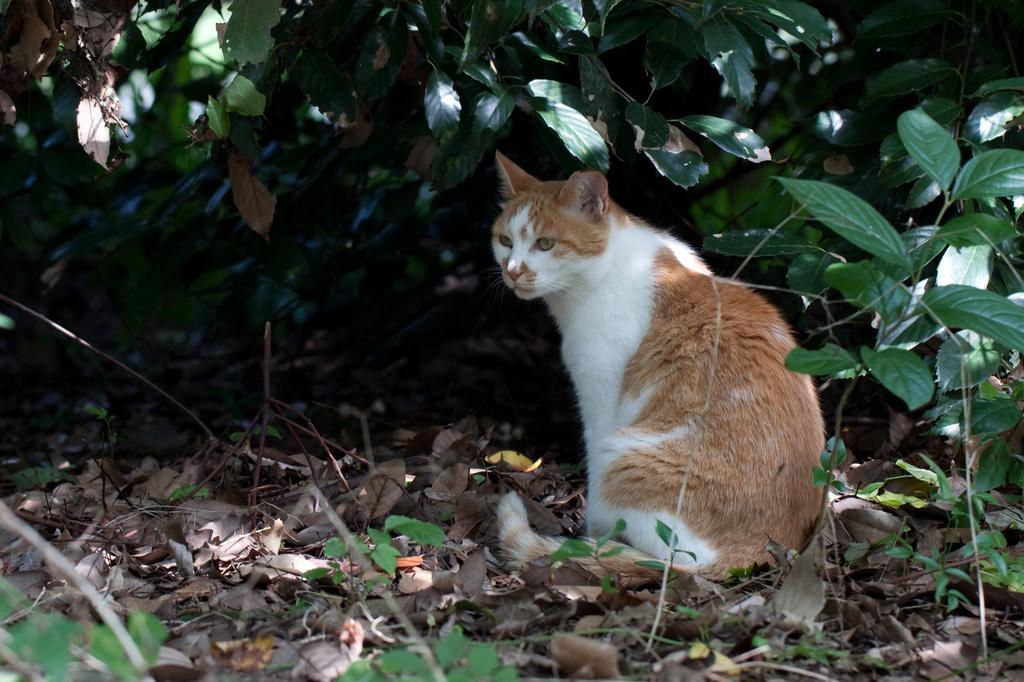Could you give a brief overview of what you see in this image? In the center of the image we can see one cat, which is brown and white color. In the background, we can see plants, dry leaves and a few other objects. 